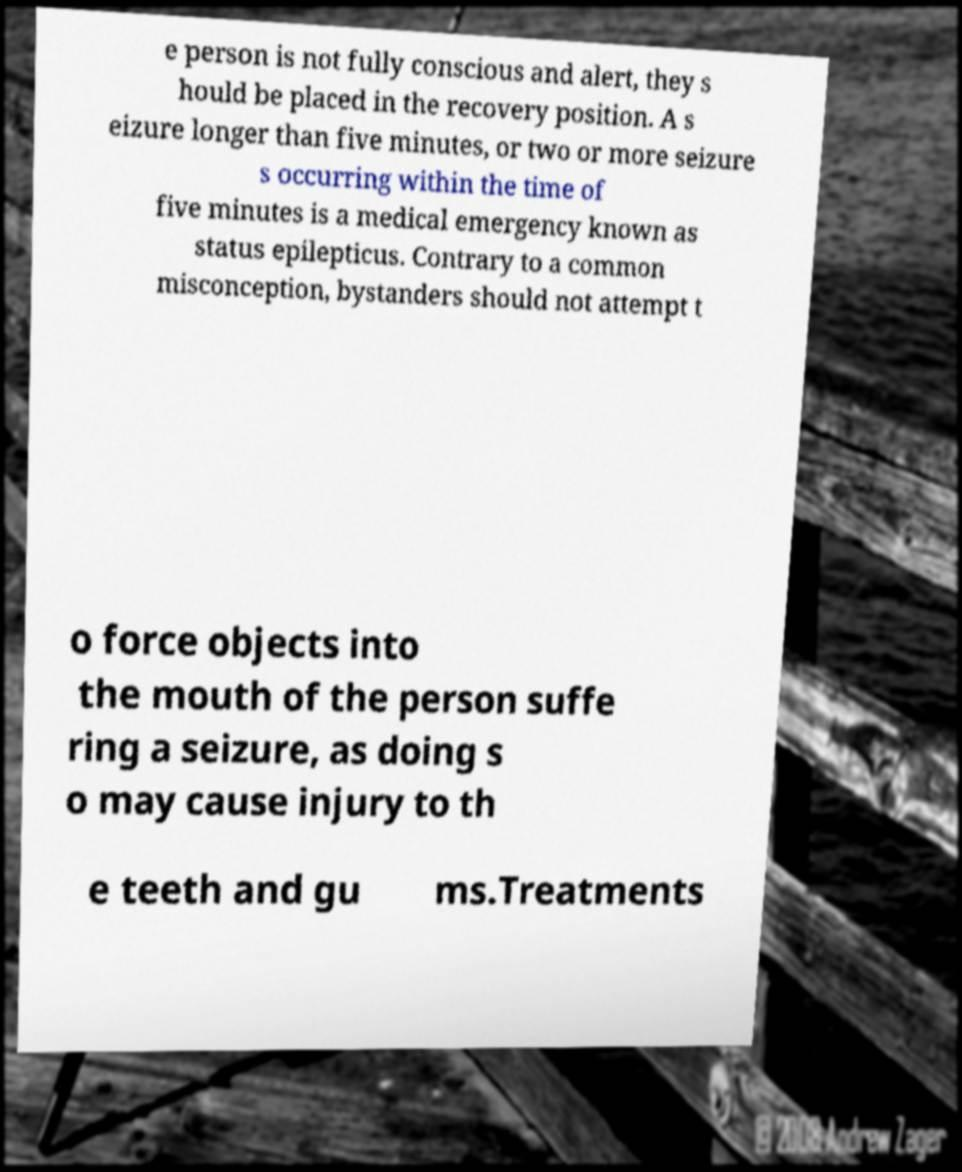Please read and relay the text visible in this image. What does it say? e person is not fully conscious and alert, they s hould be placed in the recovery position. A s eizure longer than five minutes, or two or more seizure s occurring within the time of five minutes is a medical emergency known as status epilepticus. Contrary to a common misconception, bystanders should not attempt t o force objects into the mouth of the person suffe ring a seizure, as doing s o may cause injury to th e teeth and gu ms.Treatments 